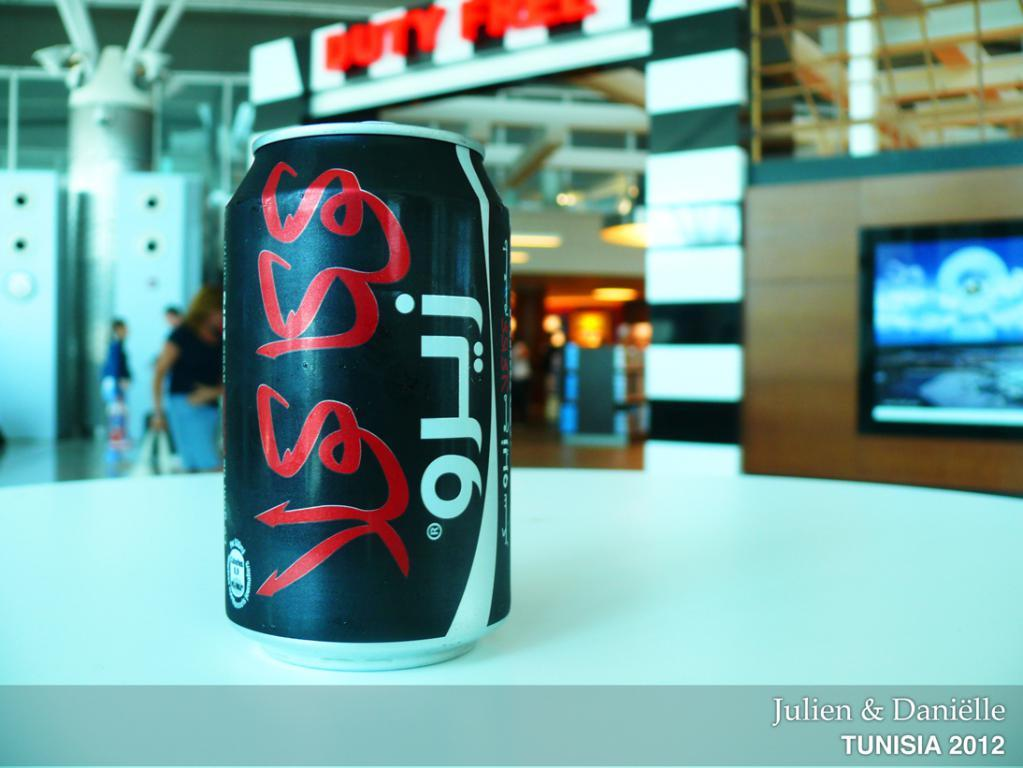<image>
Render a clear and concise summary of the photo. A can of some sort of beverage and in the corner it says Julien and Danielle. 